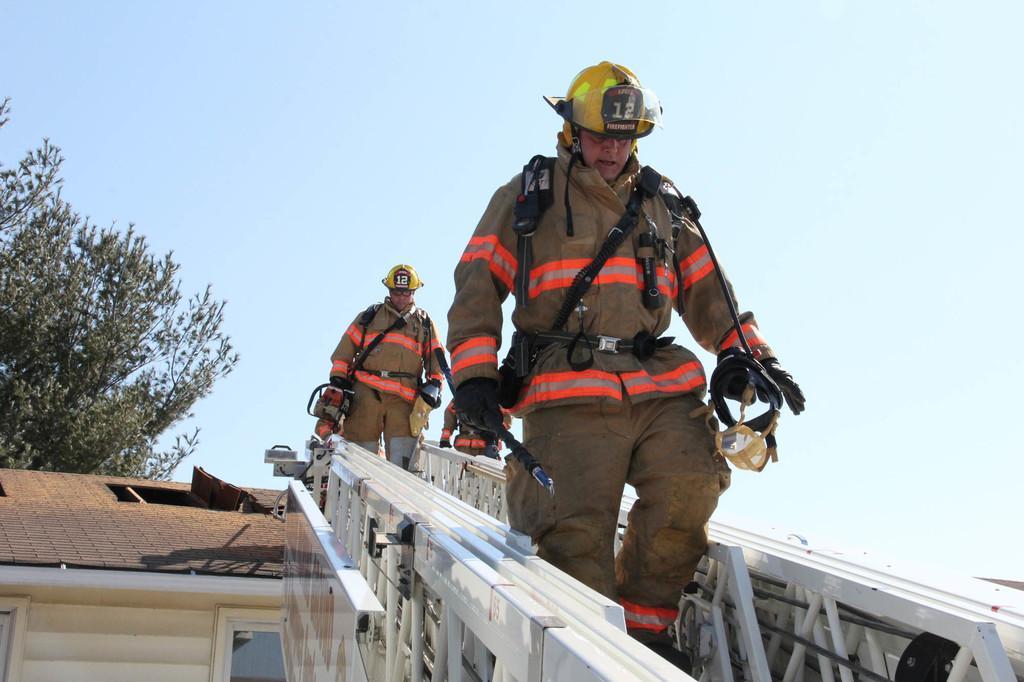Please provide a concise description of this image. In this image we can see these people wearing uniforms and helmets are walking on the ladder. Here we can see wooden house, tree and the sky in the background. 